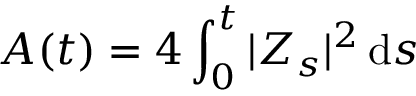<formula> <loc_0><loc_0><loc_500><loc_500>A ( t ) = 4 \int _ { 0 } ^ { t } | Z _ { s } | ^ { 2 } \, d s</formula> 